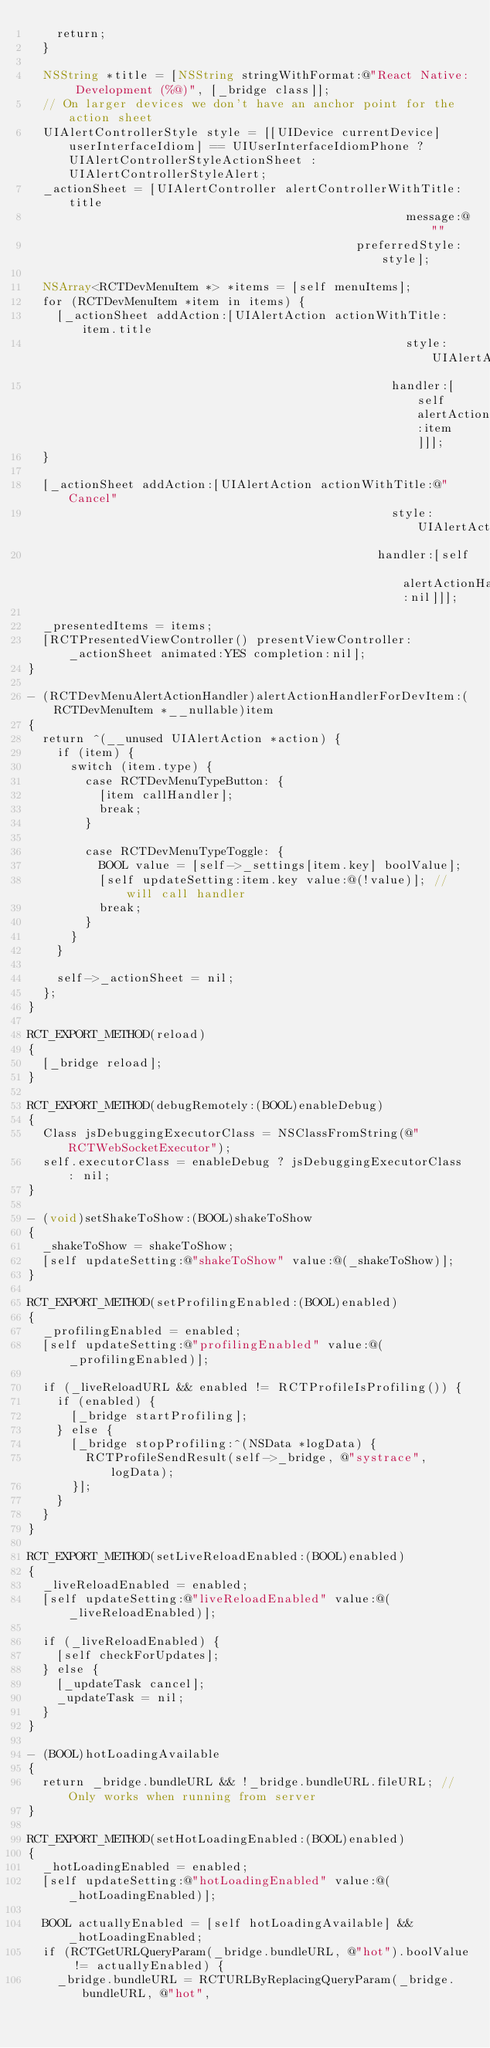<code> <loc_0><loc_0><loc_500><loc_500><_ObjectiveC_>    return;
  }

  NSString *title = [NSString stringWithFormat:@"React Native: Development (%@)", [_bridge class]];
  // On larger devices we don't have an anchor point for the action sheet
  UIAlertControllerStyle style = [[UIDevice currentDevice] userInterfaceIdiom] == UIUserInterfaceIdiomPhone ? UIAlertControllerStyleActionSheet : UIAlertControllerStyleAlert;
  _actionSheet = [UIAlertController alertControllerWithTitle:title
                                                     message:@""
                                              preferredStyle:style];

  NSArray<RCTDevMenuItem *> *items = [self menuItems];
  for (RCTDevMenuItem *item in items) {
    [_actionSheet addAction:[UIAlertAction actionWithTitle:item.title
                                                     style:UIAlertActionStyleDefault
                                                   handler:[self alertActionHandlerForDevItem:item]]];
  }

  [_actionSheet addAction:[UIAlertAction actionWithTitle:@"Cancel"
                                                   style:UIAlertActionStyleCancel
                                                 handler:[self alertActionHandlerForDevItem:nil]]];

  _presentedItems = items;
  [RCTPresentedViewController() presentViewController:_actionSheet animated:YES completion:nil];
}

- (RCTDevMenuAlertActionHandler)alertActionHandlerForDevItem:(RCTDevMenuItem *__nullable)item
{
  return ^(__unused UIAlertAction *action) {
    if (item) {
      switch (item.type) {
        case RCTDevMenuTypeButton: {
          [item callHandler];
          break;
        }

        case RCTDevMenuTypeToggle: {
          BOOL value = [self->_settings[item.key] boolValue];
          [self updateSetting:item.key value:@(!value)]; // will call handler
          break;
        }
      }
    }

    self->_actionSheet = nil;
  };
}

RCT_EXPORT_METHOD(reload)
{
  [_bridge reload];
}

RCT_EXPORT_METHOD(debugRemotely:(BOOL)enableDebug)
{
  Class jsDebuggingExecutorClass = NSClassFromString(@"RCTWebSocketExecutor");
  self.executorClass = enableDebug ? jsDebuggingExecutorClass : nil;
}

- (void)setShakeToShow:(BOOL)shakeToShow
{
  _shakeToShow = shakeToShow;
  [self updateSetting:@"shakeToShow" value:@(_shakeToShow)];
}

RCT_EXPORT_METHOD(setProfilingEnabled:(BOOL)enabled)
{
  _profilingEnabled = enabled;
  [self updateSetting:@"profilingEnabled" value:@(_profilingEnabled)];

  if (_liveReloadURL && enabled != RCTProfileIsProfiling()) {
    if (enabled) {
      [_bridge startProfiling];
    } else {
      [_bridge stopProfiling:^(NSData *logData) {
        RCTProfileSendResult(self->_bridge, @"systrace", logData);
      }];
    }
  }
}

RCT_EXPORT_METHOD(setLiveReloadEnabled:(BOOL)enabled)
{
  _liveReloadEnabled = enabled;
  [self updateSetting:@"liveReloadEnabled" value:@(_liveReloadEnabled)];

  if (_liveReloadEnabled) {
    [self checkForUpdates];
  } else {
    [_updateTask cancel];
    _updateTask = nil;
  }
}

- (BOOL)hotLoadingAvailable
{
  return _bridge.bundleURL && !_bridge.bundleURL.fileURL; // Only works when running from server
}

RCT_EXPORT_METHOD(setHotLoadingEnabled:(BOOL)enabled)
{
  _hotLoadingEnabled = enabled;
  [self updateSetting:@"hotLoadingEnabled" value:@(_hotLoadingEnabled)];

  BOOL actuallyEnabled = [self hotLoadingAvailable] && _hotLoadingEnabled;
  if (RCTGetURLQueryParam(_bridge.bundleURL, @"hot").boolValue != actuallyEnabled) {
    _bridge.bundleURL = RCTURLByReplacingQueryParam(_bridge.bundleURL, @"hot",</code> 